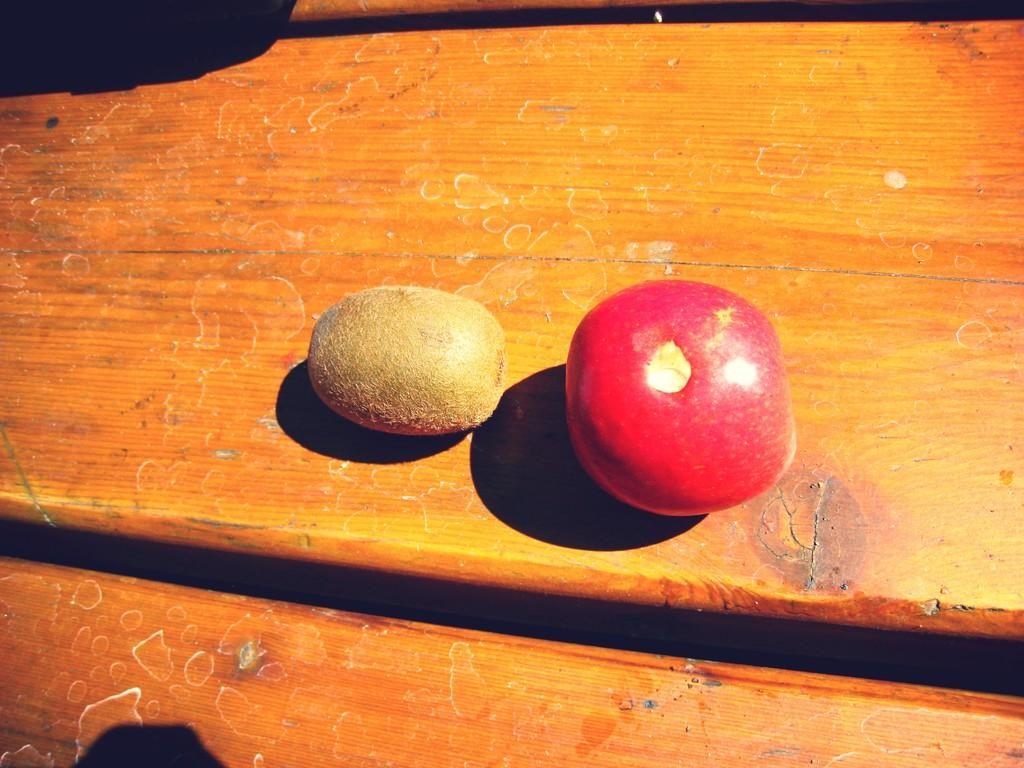What type of food can be seen in the image? There are fruits in the image. Can you describe the wooden object in the background of the image? Unfortunately, the provided facts do not give any details about the wooden object in the background. What type of committee is meeting in the image? There is no committee present in the image; it features fruits and a wooden object in the background. 